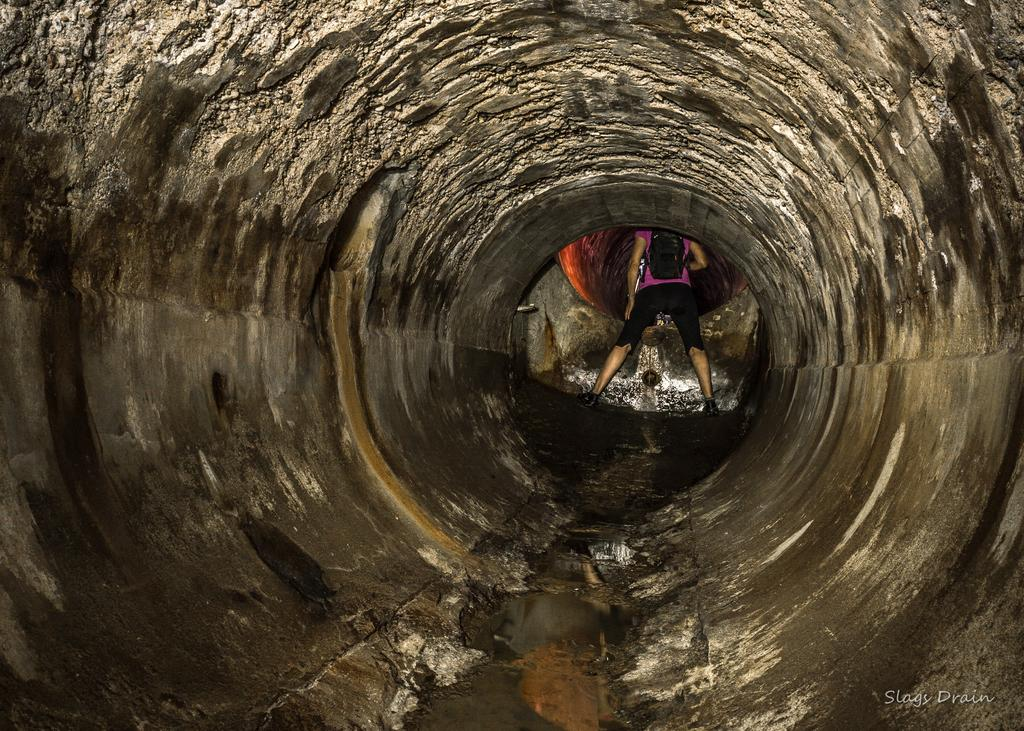What is the main subject of the image? There is a person standing in the image. What can be observed about the person's attire? The person is wearing clothes and shoes. What is the person doing with the bag in the image? The person is hanging a bag on their back. What is the nature of the watermark in the image? This is a watermark in the image. What type of environment is depicted in the image? There is water visible in the image. What color is the crayon the person is using to solve the riddle in the image? There is no crayon or riddle present in the image. How does the person's mind process the information in the image? The image does not provide any insight into the person's mental processes. 